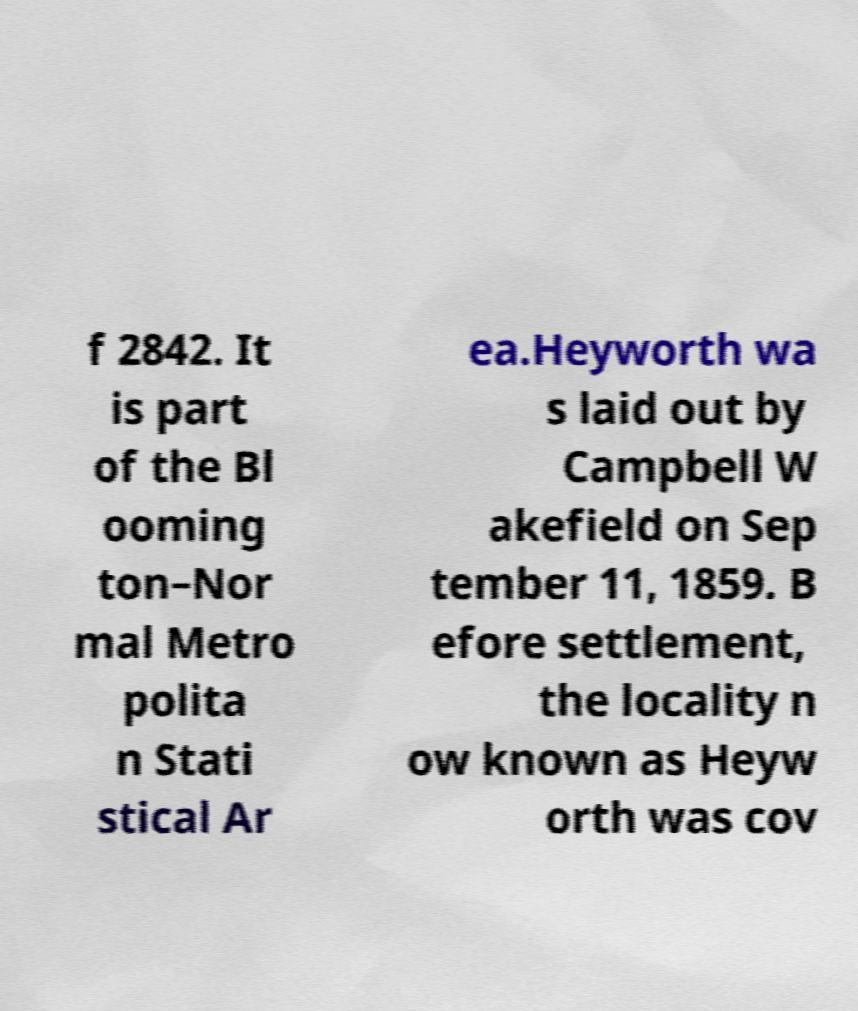Can you accurately transcribe the text from the provided image for me? f 2842. It is part of the Bl ooming ton–Nor mal Metro polita n Stati stical Ar ea.Heyworth wa s laid out by Campbell W akefield on Sep tember 11, 1859. B efore settlement, the locality n ow known as Heyw orth was cov 